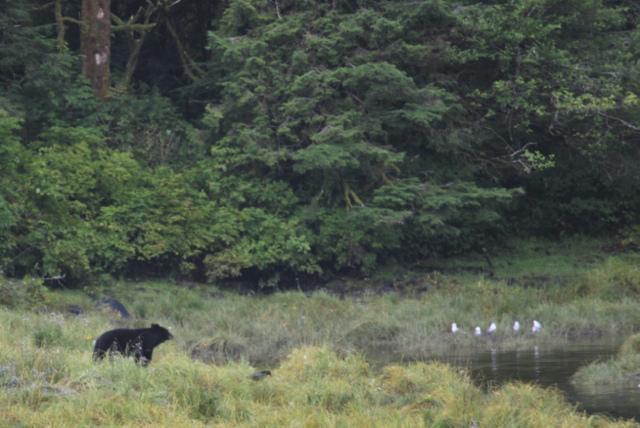How many birds are pictured?
Give a very brief answer. 5. How many people are wearing a tie in the picture?
Give a very brief answer. 0. 